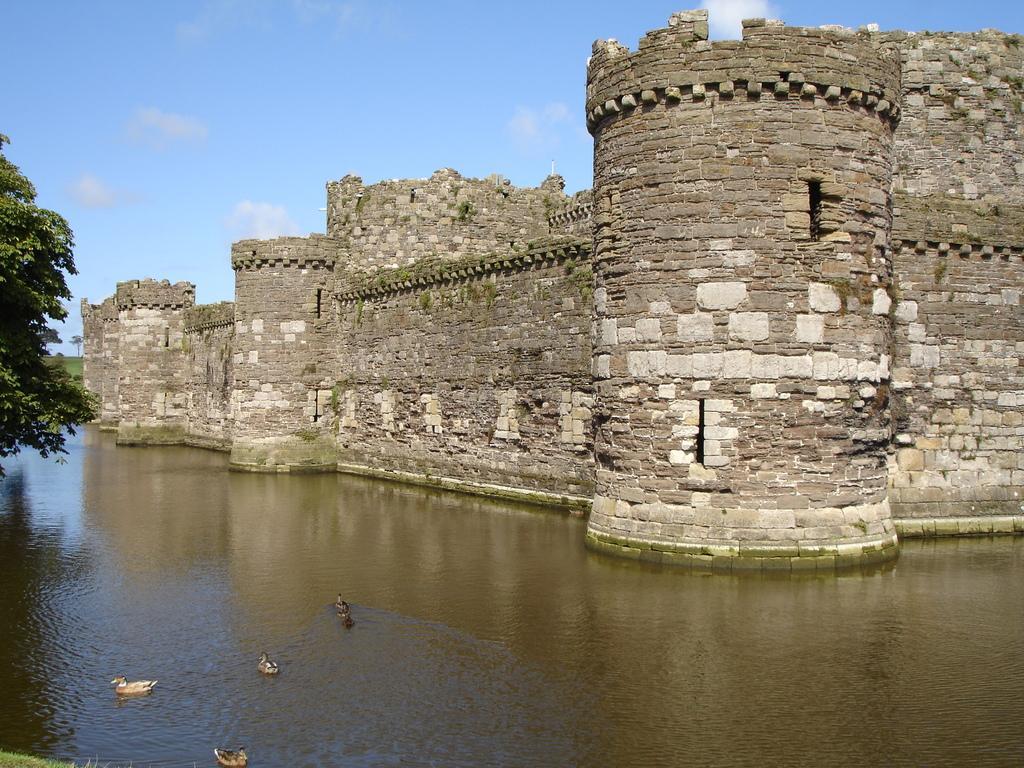How would you summarize this image in a sentence or two? In this image there are birds, water, trees, sky, grass and fort. 